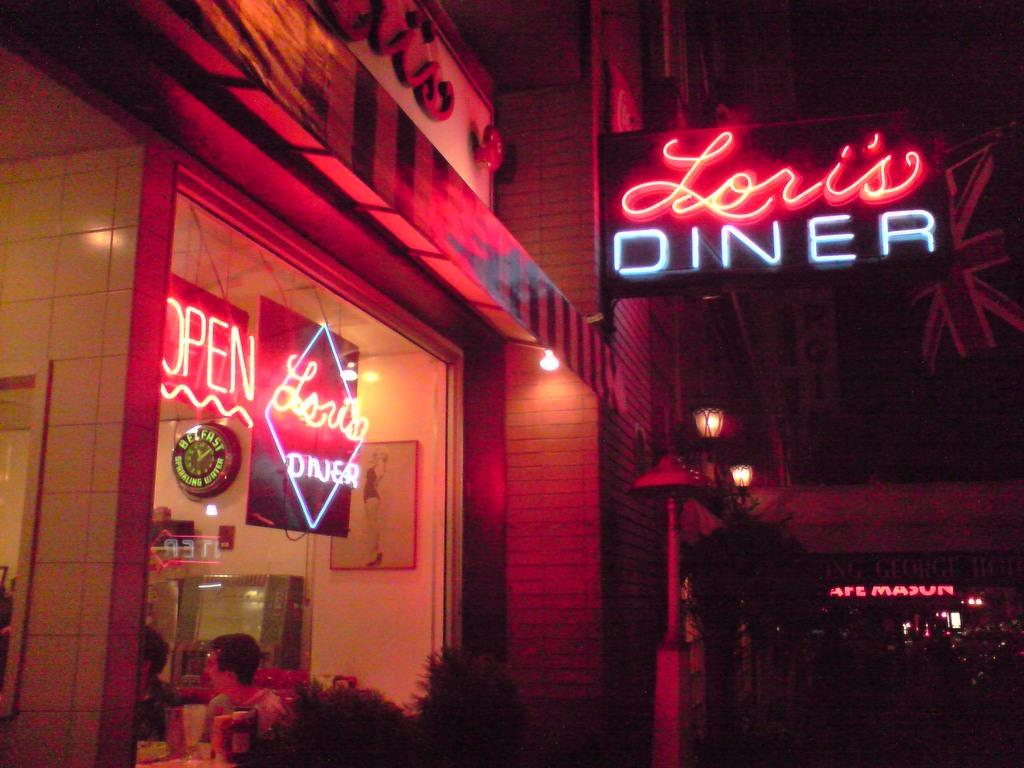Provide a one-sentence caption for the provided image. Diner with people indoors and a large sign outdoors saying Lori's Diner. 